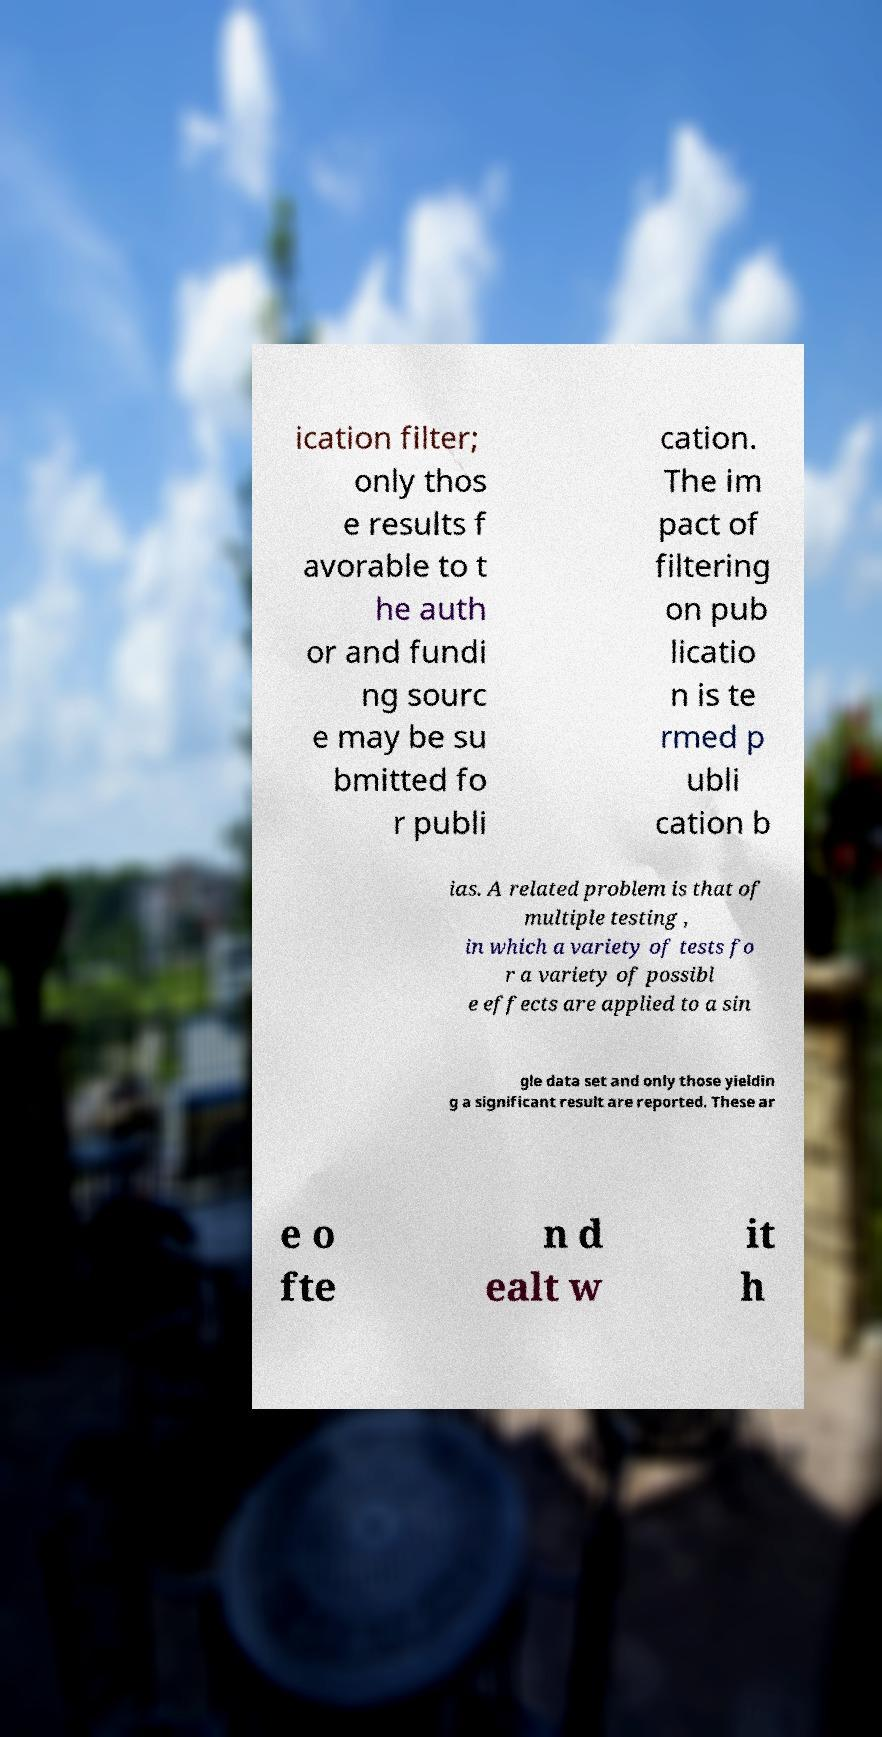What messages or text are displayed in this image? I need them in a readable, typed format. ication filter; only thos e results f avorable to t he auth or and fundi ng sourc e may be su bmitted fo r publi cation. The im pact of filtering on pub licatio n is te rmed p ubli cation b ias. A related problem is that of multiple testing , in which a variety of tests fo r a variety of possibl e effects are applied to a sin gle data set and only those yieldin g a significant result are reported. These ar e o fte n d ealt w it h 